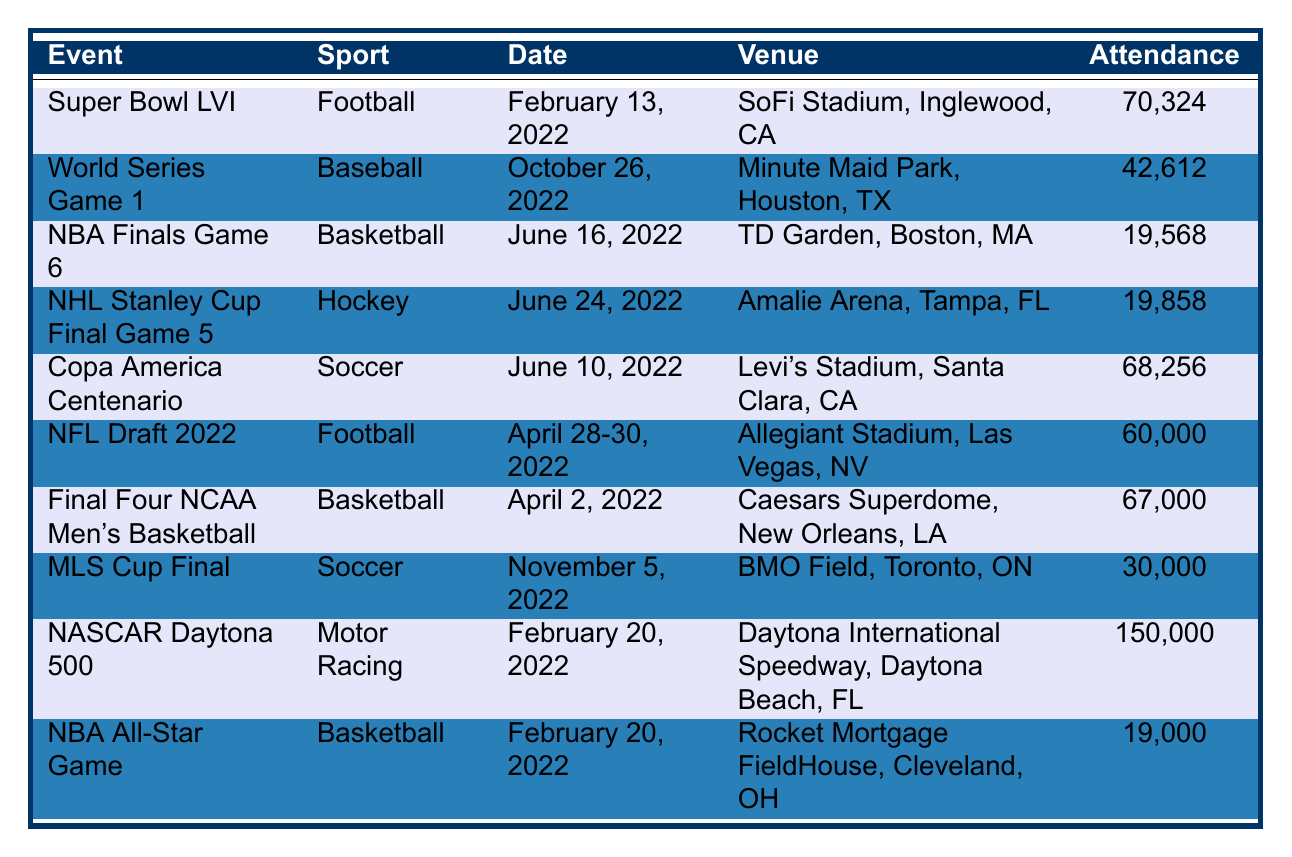What is the attendance for the Super Bowl LVI? According to the table, the attendance figure listed for the Super Bowl LVI is 70,324.
Answer: 70,324 Which event had the highest attendance in 2022? By reviewing the attendance figures in the table, NASCAR Daytona 500 shows the highest attendance of 150,000.
Answer: 150,000 How many people attended the NBA Finals Game 6? The attendance for the NBA Finals Game 6 is provided in the table as 19,568.
Answer: 19,568 What was the attendance for the NHL Stanley Cup Final Game 5? The table indicates that the NHL Stanley Cup Final Game 5 had an attendance of 19,858.
Answer: 19,858 Was the attendance for the World Series Game 1 greater than 40,000? Checking the table, the attendance for the World Series Game 1 is 42,612, which is indeed greater than 40,000.
Answer: Yes What is the total attendance for the Final Four NCAA Men’s Basketball and the NBA All-Star Game combined? To find the total, we add the attendances: Final Four NCAA Men's Basketball (67,000) + NBA All-Star Game (19,000) = 86,000.
Answer: 86,000 Is the attendance for the Copa America Centenario less than the Final Four NCAA Men's Basketball? The attendance for Copa America Centenario is 68,256 and for Final Four NCAA Men's Basketball is 67,000. Since 68,256 is greater than 67,000, the statement is false.
Answer: No How many events listed had an attendance of over 60,000? From the table, we can see that Super Bowl LVI, NASCAR Daytona 500, Final Four NCAA Men's Basketball, and Copa America Centenario all have attendances over 60,000. There are 4 such events.
Answer: 4 What is the average attendance of the events listed in the table? To calculate the average, we sum all the attendance figures: 70,324 + 42,612 + 19,568 + 19,858 + 68,256 + 60,000 + 67,000 + 30,000 + 150,000 + 19,000 =  500,588. Then we divide by the number of events (10), resulting in 500,588 / 10 = 50,058.8.
Answer: 50,058.8 Which sports had an event with attendance below 20,000? Reviewing the table, only the NBA Finals Game 6 (19,568) and NBA All-Star Game (19,000) are below 20,000. Thus, Basketball is the only sport that had such events.
Answer: Basketball 